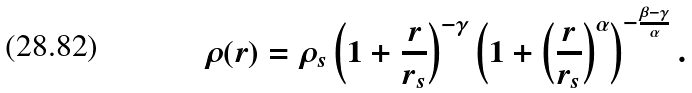<formula> <loc_0><loc_0><loc_500><loc_500>\rho ( r ) = \rho _ { s } \left ( 1 + \frac { r } { r _ { s } } \right ) ^ { - \gamma } \left ( 1 + \left ( \frac { r } { r _ { s } } \right ) ^ { \alpha } \right ) ^ { - \frac { \beta - \gamma } { \alpha } } .</formula> 